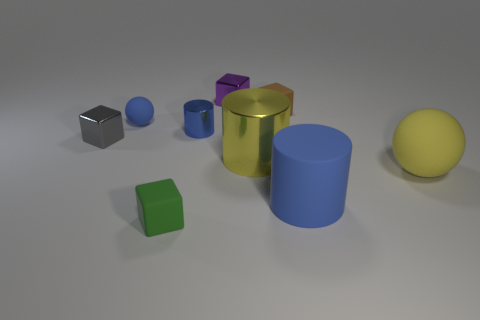Could you tell me which objects appear to be metallic? Certainly, the objects that exhibit metallic properties are the silver cube and the golden cylinder. Their reflective surfaces and color suggest that they are made of metal. 